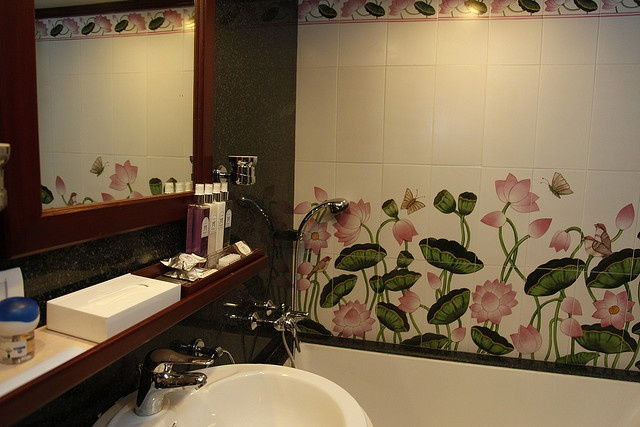Describe the objects in this image and their specific colors. I can see a sink in black, tan, and gray tones in this image. 